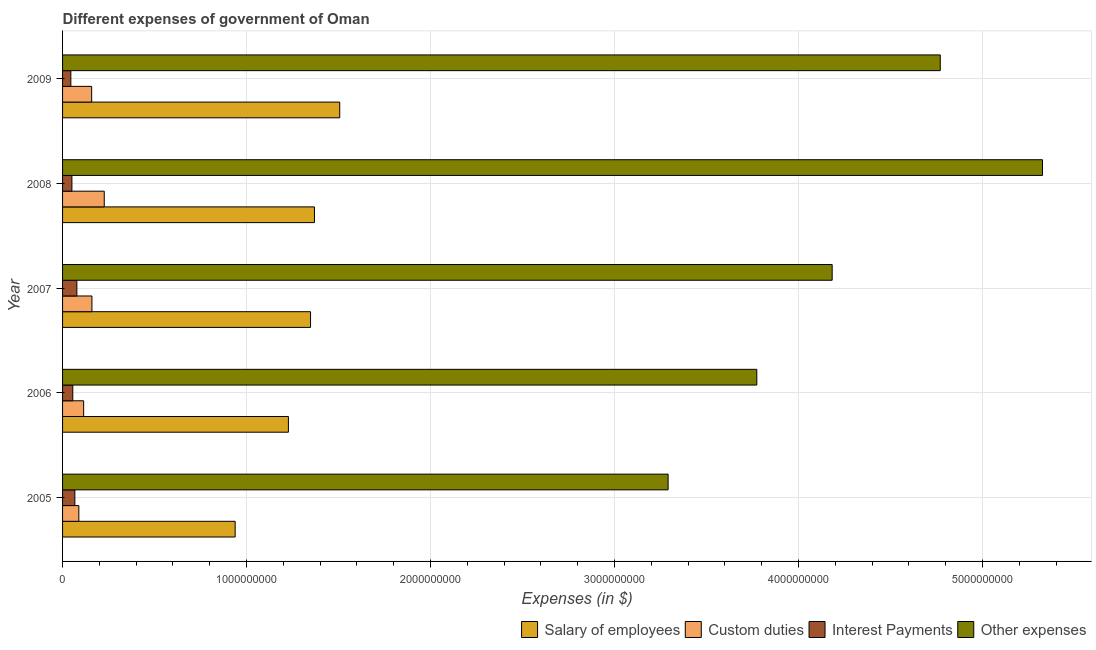Are the number of bars on each tick of the Y-axis equal?
Ensure brevity in your answer.  Yes. How many bars are there on the 1st tick from the bottom?
Keep it short and to the point. 4. What is the label of the 2nd group of bars from the top?
Ensure brevity in your answer.  2008. In how many cases, is the number of bars for a given year not equal to the number of legend labels?
Ensure brevity in your answer.  0. What is the amount spent on interest payments in 2005?
Your answer should be very brief. 6.68e+07. Across all years, what is the maximum amount spent on custom duties?
Make the answer very short. 2.27e+08. Across all years, what is the minimum amount spent on interest payments?
Your response must be concise. 4.50e+07. In which year was the amount spent on interest payments maximum?
Offer a very short reply. 2007. What is the total amount spent on custom duties in the graph?
Ensure brevity in your answer.  7.47e+08. What is the difference between the amount spent on other expenses in 2005 and that in 2007?
Ensure brevity in your answer.  -8.92e+08. What is the difference between the amount spent on salary of employees in 2009 and the amount spent on custom duties in 2005?
Make the answer very short. 1.42e+09. What is the average amount spent on salary of employees per year?
Offer a terse response. 1.28e+09. In the year 2005, what is the difference between the amount spent on interest payments and amount spent on custom duties?
Your response must be concise. -2.17e+07. In how many years, is the amount spent on custom duties greater than 3600000000 $?
Give a very brief answer. 0. What is the ratio of the amount spent on salary of employees in 2006 to that in 2009?
Your answer should be very brief. 0.81. Is the difference between the amount spent on salary of employees in 2005 and 2007 greater than the difference between the amount spent on other expenses in 2005 and 2007?
Make the answer very short. Yes. What is the difference between the highest and the second highest amount spent on salary of employees?
Offer a terse response. 1.37e+08. What is the difference between the highest and the lowest amount spent on custom duties?
Make the answer very short. 1.38e+08. Is it the case that in every year, the sum of the amount spent on interest payments and amount spent on salary of employees is greater than the sum of amount spent on custom duties and amount spent on other expenses?
Provide a succinct answer. No. What does the 4th bar from the top in 2005 represents?
Give a very brief answer. Salary of employees. What does the 1st bar from the bottom in 2007 represents?
Provide a short and direct response. Salary of employees. Is it the case that in every year, the sum of the amount spent on salary of employees and amount spent on custom duties is greater than the amount spent on interest payments?
Keep it short and to the point. Yes. How many bars are there?
Ensure brevity in your answer.  20. Are all the bars in the graph horizontal?
Give a very brief answer. Yes. What is the difference between two consecutive major ticks on the X-axis?
Ensure brevity in your answer.  1.00e+09. Does the graph contain grids?
Your response must be concise. Yes. Where does the legend appear in the graph?
Your answer should be compact. Bottom right. How many legend labels are there?
Keep it short and to the point. 4. How are the legend labels stacked?
Make the answer very short. Horizontal. What is the title of the graph?
Offer a very short reply. Different expenses of government of Oman. Does "First 20% of population" appear as one of the legend labels in the graph?
Your response must be concise. No. What is the label or title of the X-axis?
Your response must be concise. Expenses (in $). What is the label or title of the Y-axis?
Your answer should be compact. Year. What is the Expenses (in $) of Salary of employees in 2005?
Ensure brevity in your answer.  9.38e+08. What is the Expenses (in $) in Custom duties in 2005?
Give a very brief answer. 8.85e+07. What is the Expenses (in $) in Interest Payments in 2005?
Give a very brief answer. 6.68e+07. What is the Expenses (in $) in Other expenses in 2005?
Your response must be concise. 3.29e+09. What is the Expenses (in $) in Salary of employees in 2006?
Provide a succinct answer. 1.23e+09. What is the Expenses (in $) of Custom duties in 2006?
Keep it short and to the point. 1.15e+08. What is the Expenses (in $) in Interest Payments in 2006?
Your answer should be very brief. 5.56e+07. What is the Expenses (in $) in Other expenses in 2006?
Offer a terse response. 3.77e+09. What is the Expenses (in $) of Salary of employees in 2007?
Make the answer very short. 1.35e+09. What is the Expenses (in $) of Custom duties in 2007?
Give a very brief answer. 1.60e+08. What is the Expenses (in $) in Interest Payments in 2007?
Provide a short and direct response. 7.77e+07. What is the Expenses (in $) of Other expenses in 2007?
Provide a succinct answer. 4.18e+09. What is the Expenses (in $) in Salary of employees in 2008?
Make the answer very short. 1.37e+09. What is the Expenses (in $) in Custom duties in 2008?
Your answer should be compact. 2.27e+08. What is the Expenses (in $) of Interest Payments in 2008?
Provide a short and direct response. 5.08e+07. What is the Expenses (in $) of Other expenses in 2008?
Keep it short and to the point. 5.33e+09. What is the Expenses (in $) of Salary of employees in 2009?
Provide a short and direct response. 1.51e+09. What is the Expenses (in $) in Custom duties in 2009?
Offer a very short reply. 1.58e+08. What is the Expenses (in $) in Interest Payments in 2009?
Your answer should be very brief. 4.50e+07. What is the Expenses (in $) of Other expenses in 2009?
Give a very brief answer. 4.77e+09. Across all years, what is the maximum Expenses (in $) of Salary of employees?
Provide a succinct answer. 1.51e+09. Across all years, what is the maximum Expenses (in $) in Custom duties?
Your answer should be compact. 2.27e+08. Across all years, what is the maximum Expenses (in $) in Interest Payments?
Your response must be concise. 7.77e+07. Across all years, what is the maximum Expenses (in $) in Other expenses?
Provide a short and direct response. 5.33e+09. Across all years, what is the minimum Expenses (in $) in Salary of employees?
Make the answer very short. 9.38e+08. Across all years, what is the minimum Expenses (in $) of Custom duties?
Make the answer very short. 8.85e+07. Across all years, what is the minimum Expenses (in $) of Interest Payments?
Your answer should be very brief. 4.50e+07. Across all years, what is the minimum Expenses (in $) of Other expenses?
Provide a short and direct response. 3.29e+09. What is the total Expenses (in $) of Salary of employees in the graph?
Your answer should be compact. 6.39e+09. What is the total Expenses (in $) in Custom duties in the graph?
Your response must be concise. 7.47e+08. What is the total Expenses (in $) in Interest Payments in the graph?
Offer a terse response. 2.96e+08. What is the total Expenses (in $) in Other expenses in the graph?
Provide a short and direct response. 2.13e+1. What is the difference between the Expenses (in $) in Salary of employees in 2005 and that in 2006?
Give a very brief answer. -2.89e+08. What is the difference between the Expenses (in $) in Custom duties in 2005 and that in 2006?
Offer a very short reply. -2.61e+07. What is the difference between the Expenses (in $) in Interest Payments in 2005 and that in 2006?
Provide a succinct answer. 1.12e+07. What is the difference between the Expenses (in $) of Other expenses in 2005 and that in 2006?
Provide a succinct answer. -4.82e+08. What is the difference between the Expenses (in $) of Salary of employees in 2005 and that in 2007?
Keep it short and to the point. -4.10e+08. What is the difference between the Expenses (in $) of Custom duties in 2005 and that in 2007?
Your response must be concise. -7.11e+07. What is the difference between the Expenses (in $) in Interest Payments in 2005 and that in 2007?
Your answer should be compact. -1.09e+07. What is the difference between the Expenses (in $) of Other expenses in 2005 and that in 2007?
Ensure brevity in your answer.  -8.92e+08. What is the difference between the Expenses (in $) in Salary of employees in 2005 and that in 2008?
Offer a terse response. -4.31e+08. What is the difference between the Expenses (in $) in Custom duties in 2005 and that in 2008?
Provide a succinct answer. -1.38e+08. What is the difference between the Expenses (in $) of Interest Payments in 2005 and that in 2008?
Give a very brief answer. 1.60e+07. What is the difference between the Expenses (in $) of Other expenses in 2005 and that in 2008?
Make the answer very short. -2.03e+09. What is the difference between the Expenses (in $) in Salary of employees in 2005 and that in 2009?
Make the answer very short. -5.68e+08. What is the difference between the Expenses (in $) of Custom duties in 2005 and that in 2009?
Keep it short and to the point. -6.96e+07. What is the difference between the Expenses (in $) in Interest Payments in 2005 and that in 2009?
Your answer should be compact. 2.18e+07. What is the difference between the Expenses (in $) in Other expenses in 2005 and that in 2009?
Offer a terse response. -1.48e+09. What is the difference between the Expenses (in $) of Salary of employees in 2006 and that in 2007?
Ensure brevity in your answer.  -1.20e+08. What is the difference between the Expenses (in $) of Custom duties in 2006 and that in 2007?
Provide a succinct answer. -4.50e+07. What is the difference between the Expenses (in $) in Interest Payments in 2006 and that in 2007?
Offer a very short reply. -2.21e+07. What is the difference between the Expenses (in $) in Other expenses in 2006 and that in 2007?
Provide a short and direct response. -4.10e+08. What is the difference between the Expenses (in $) in Salary of employees in 2006 and that in 2008?
Keep it short and to the point. -1.42e+08. What is the difference between the Expenses (in $) in Custom duties in 2006 and that in 2008?
Ensure brevity in your answer.  -1.12e+08. What is the difference between the Expenses (in $) in Interest Payments in 2006 and that in 2008?
Offer a very short reply. 4.80e+06. What is the difference between the Expenses (in $) in Other expenses in 2006 and that in 2008?
Keep it short and to the point. -1.55e+09. What is the difference between the Expenses (in $) of Salary of employees in 2006 and that in 2009?
Offer a very short reply. -2.79e+08. What is the difference between the Expenses (in $) of Custom duties in 2006 and that in 2009?
Provide a succinct answer. -4.35e+07. What is the difference between the Expenses (in $) of Interest Payments in 2006 and that in 2009?
Ensure brevity in your answer.  1.06e+07. What is the difference between the Expenses (in $) in Other expenses in 2006 and that in 2009?
Ensure brevity in your answer.  -9.97e+08. What is the difference between the Expenses (in $) in Salary of employees in 2007 and that in 2008?
Your answer should be compact. -2.13e+07. What is the difference between the Expenses (in $) of Custom duties in 2007 and that in 2008?
Offer a very short reply. -6.70e+07. What is the difference between the Expenses (in $) in Interest Payments in 2007 and that in 2008?
Your response must be concise. 2.69e+07. What is the difference between the Expenses (in $) of Other expenses in 2007 and that in 2008?
Keep it short and to the point. -1.14e+09. What is the difference between the Expenses (in $) in Salary of employees in 2007 and that in 2009?
Offer a very short reply. -1.59e+08. What is the difference between the Expenses (in $) in Custom duties in 2007 and that in 2009?
Your answer should be compact. 1.50e+06. What is the difference between the Expenses (in $) of Interest Payments in 2007 and that in 2009?
Give a very brief answer. 3.27e+07. What is the difference between the Expenses (in $) in Other expenses in 2007 and that in 2009?
Your answer should be compact. -5.88e+08. What is the difference between the Expenses (in $) in Salary of employees in 2008 and that in 2009?
Your response must be concise. -1.37e+08. What is the difference between the Expenses (in $) in Custom duties in 2008 and that in 2009?
Your answer should be very brief. 6.85e+07. What is the difference between the Expenses (in $) of Interest Payments in 2008 and that in 2009?
Offer a very short reply. 5.80e+06. What is the difference between the Expenses (in $) in Other expenses in 2008 and that in 2009?
Offer a terse response. 5.56e+08. What is the difference between the Expenses (in $) in Salary of employees in 2005 and the Expenses (in $) in Custom duties in 2006?
Offer a terse response. 8.24e+08. What is the difference between the Expenses (in $) of Salary of employees in 2005 and the Expenses (in $) of Interest Payments in 2006?
Give a very brief answer. 8.82e+08. What is the difference between the Expenses (in $) in Salary of employees in 2005 and the Expenses (in $) in Other expenses in 2006?
Give a very brief answer. -2.84e+09. What is the difference between the Expenses (in $) in Custom duties in 2005 and the Expenses (in $) in Interest Payments in 2006?
Your response must be concise. 3.29e+07. What is the difference between the Expenses (in $) in Custom duties in 2005 and the Expenses (in $) in Other expenses in 2006?
Make the answer very short. -3.68e+09. What is the difference between the Expenses (in $) in Interest Payments in 2005 and the Expenses (in $) in Other expenses in 2006?
Give a very brief answer. -3.71e+09. What is the difference between the Expenses (in $) in Salary of employees in 2005 and the Expenses (in $) in Custom duties in 2007?
Keep it short and to the point. 7.78e+08. What is the difference between the Expenses (in $) in Salary of employees in 2005 and the Expenses (in $) in Interest Payments in 2007?
Offer a very short reply. 8.60e+08. What is the difference between the Expenses (in $) in Salary of employees in 2005 and the Expenses (in $) in Other expenses in 2007?
Provide a succinct answer. -3.24e+09. What is the difference between the Expenses (in $) of Custom duties in 2005 and the Expenses (in $) of Interest Payments in 2007?
Keep it short and to the point. 1.08e+07. What is the difference between the Expenses (in $) in Custom duties in 2005 and the Expenses (in $) in Other expenses in 2007?
Provide a succinct answer. -4.09e+09. What is the difference between the Expenses (in $) in Interest Payments in 2005 and the Expenses (in $) in Other expenses in 2007?
Make the answer very short. -4.12e+09. What is the difference between the Expenses (in $) in Salary of employees in 2005 and the Expenses (in $) in Custom duties in 2008?
Make the answer very short. 7.12e+08. What is the difference between the Expenses (in $) of Salary of employees in 2005 and the Expenses (in $) of Interest Payments in 2008?
Provide a short and direct response. 8.87e+08. What is the difference between the Expenses (in $) in Salary of employees in 2005 and the Expenses (in $) in Other expenses in 2008?
Give a very brief answer. -4.39e+09. What is the difference between the Expenses (in $) of Custom duties in 2005 and the Expenses (in $) of Interest Payments in 2008?
Give a very brief answer. 3.77e+07. What is the difference between the Expenses (in $) of Custom duties in 2005 and the Expenses (in $) of Other expenses in 2008?
Offer a very short reply. -5.24e+09. What is the difference between the Expenses (in $) in Interest Payments in 2005 and the Expenses (in $) in Other expenses in 2008?
Offer a terse response. -5.26e+09. What is the difference between the Expenses (in $) in Salary of employees in 2005 and the Expenses (in $) in Custom duties in 2009?
Offer a very short reply. 7.80e+08. What is the difference between the Expenses (in $) in Salary of employees in 2005 and the Expenses (in $) in Interest Payments in 2009?
Your response must be concise. 8.93e+08. What is the difference between the Expenses (in $) of Salary of employees in 2005 and the Expenses (in $) of Other expenses in 2009?
Offer a very short reply. -3.83e+09. What is the difference between the Expenses (in $) in Custom duties in 2005 and the Expenses (in $) in Interest Payments in 2009?
Make the answer very short. 4.35e+07. What is the difference between the Expenses (in $) in Custom duties in 2005 and the Expenses (in $) in Other expenses in 2009?
Keep it short and to the point. -4.68e+09. What is the difference between the Expenses (in $) in Interest Payments in 2005 and the Expenses (in $) in Other expenses in 2009?
Offer a very short reply. -4.70e+09. What is the difference between the Expenses (in $) of Salary of employees in 2006 and the Expenses (in $) of Custom duties in 2007?
Ensure brevity in your answer.  1.07e+09. What is the difference between the Expenses (in $) in Salary of employees in 2006 and the Expenses (in $) in Interest Payments in 2007?
Provide a succinct answer. 1.15e+09. What is the difference between the Expenses (in $) of Salary of employees in 2006 and the Expenses (in $) of Other expenses in 2007?
Your answer should be compact. -2.96e+09. What is the difference between the Expenses (in $) in Custom duties in 2006 and the Expenses (in $) in Interest Payments in 2007?
Your response must be concise. 3.69e+07. What is the difference between the Expenses (in $) in Custom duties in 2006 and the Expenses (in $) in Other expenses in 2007?
Provide a short and direct response. -4.07e+09. What is the difference between the Expenses (in $) in Interest Payments in 2006 and the Expenses (in $) in Other expenses in 2007?
Provide a succinct answer. -4.13e+09. What is the difference between the Expenses (in $) in Salary of employees in 2006 and the Expenses (in $) in Custom duties in 2008?
Make the answer very short. 1.00e+09. What is the difference between the Expenses (in $) in Salary of employees in 2006 and the Expenses (in $) in Interest Payments in 2008?
Offer a terse response. 1.18e+09. What is the difference between the Expenses (in $) in Salary of employees in 2006 and the Expenses (in $) in Other expenses in 2008?
Offer a very short reply. -4.10e+09. What is the difference between the Expenses (in $) in Custom duties in 2006 and the Expenses (in $) in Interest Payments in 2008?
Your answer should be compact. 6.38e+07. What is the difference between the Expenses (in $) in Custom duties in 2006 and the Expenses (in $) in Other expenses in 2008?
Give a very brief answer. -5.21e+09. What is the difference between the Expenses (in $) of Interest Payments in 2006 and the Expenses (in $) of Other expenses in 2008?
Your answer should be very brief. -5.27e+09. What is the difference between the Expenses (in $) of Salary of employees in 2006 and the Expenses (in $) of Custom duties in 2009?
Offer a very short reply. 1.07e+09. What is the difference between the Expenses (in $) of Salary of employees in 2006 and the Expenses (in $) of Interest Payments in 2009?
Offer a very short reply. 1.18e+09. What is the difference between the Expenses (in $) of Salary of employees in 2006 and the Expenses (in $) of Other expenses in 2009?
Give a very brief answer. -3.54e+09. What is the difference between the Expenses (in $) of Custom duties in 2006 and the Expenses (in $) of Interest Payments in 2009?
Your answer should be compact. 6.96e+07. What is the difference between the Expenses (in $) in Custom duties in 2006 and the Expenses (in $) in Other expenses in 2009?
Ensure brevity in your answer.  -4.66e+09. What is the difference between the Expenses (in $) in Interest Payments in 2006 and the Expenses (in $) in Other expenses in 2009?
Offer a very short reply. -4.72e+09. What is the difference between the Expenses (in $) of Salary of employees in 2007 and the Expenses (in $) of Custom duties in 2008?
Your answer should be compact. 1.12e+09. What is the difference between the Expenses (in $) of Salary of employees in 2007 and the Expenses (in $) of Interest Payments in 2008?
Offer a very short reply. 1.30e+09. What is the difference between the Expenses (in $) in Salary of employees in 2007 and the Expenses (in $) in Other expenses in 2008?
Ensure brevity in your answer.  -3.98e+09. What is the difference between the Expenses (in $) of Custom duties in 2007 and the Expenses (in $) of Interest Payments in 2008?
Your answer should be compact. 1.09e+08. What is the difference between the Expenses (in $) in Custom duties in 2007 and the Expenses (in $) in Other expenses in 2008?
Your answer should be very brief. -5.17e+09. What is the difference between the Expenses (in $) in Interest Payments in 2007 and the Expenses (in $) in Other expenses in 2008?
Your answer should be very brief. -5.25e+09. What is the difference between the Expenses (in $) of Salary of employees in 2007 and the Expenses (in $) of Custom duties in 2009?
Your answer should be compact. 1.19e+09. What is the difference between the Expenses (in $) in Salary of employees in 2007 and the Expenses (in $) in Interest Payments in 2009?
Provide a short and direct response. 1.30e+09. What is the difference between the Expenses (in $) in Salary of employees in 2007 and the Expenses (in $) in Other expenses in 2009?
Your answer should be very brief. -3.42e+09. What is the difference between the Expenses (in $) of Custom duties in 2007 and the Expenses (in $) of Interest Payments in 2009?
Your response must be concise. 1.15e+08. What is the difference between the Expenses (in $) of Custom duties in 2007 and the Expenses (in $) of Other expenses in 2009?
Keep it short and to the point. -4.61e+09. What is the difference between the Expenses (in $) in Interest Payments in 2007 and the Expenses (in $) in Other expenses in 2009?
Your answer should be compact. -4.69e+09. What is the difference between the Expenses (in $) in Salary of employees in 2008 and the Expenses (in $) in Custom duties in 2009?
Your response must be concise. 1.21e+09. What is the difference between the Expenses (in $) of Salary of employees in 2008 and the Expenses (in $) of Interest Payments in 2009?
Ensure brevity in your answer.  1.32e+09. What is the difference between the Expenses (in $) of Salary of employees in 2008 and the Expenses (in $) of Other expenses in 2009?
Offer a very short reply. -3.40e+09. What is the difference between the Expenses (in $) of Custom duties in 2008 and the Expenses (in $) of Interest Payments in 2009?
Provide a short and direct response. 1.82e+08. What is the difference between the Expenses (in $) in Custom duties in 2008 and the Expenses (in $) in Other expenses in 2009?
Your response must be concise. -4.54e+09. What is the difference between the Expenses (in $) in Interest Payments in 2008 and the Expenses (in $) in Other expenses in 2009?
Your answer should be very brief. -4.72e+09. What is the average Expenses (in $) in Salary of employees per year?
Provide a succinct answer. 1.28e+09. What is the average Expenses (in $) of Custom duties per year?
Give a very brief answer. 1.49e+08. What is the average Expenses (in $) of Interest Payments per year?
Offer a terse response. 5.92e+07. What is the average Expenses (in $) in Other expenses per year?
Keep it short and to the point. 4.27e+09. In the year 2005, what is the difference between the Expenses (in $) in Salary of employees and Expenses (in $) in Custom duties?
Make the answer very short. 8.50e+08. In the year 2005, what is the difference between the Expenses (in $) of Salary of employees and Expenses (in $) of Interest Payments?
Make the answer very short. 8.71e+08. In the year 2005, what is the difference between the Expenses (in $) of Salary of employees and Expenses (in $) of Other expenses?
Provide a short and direct response. -2.35e+09. In the year 2005, what is the difference between the Expenses (in $) in Custom duties and Expenses (in $) in Interest Payments?
Your answer should be compact. 2.17e+07. In the year 2005, what is the difference between the Expenses (in $) of Custom duties and Expenses (in $) of Other expenses?
Give a very brief answer. -3.20e+09. In the year 2005, what is the difference between the Expenses (in $) of Interest Payments and Expenses (in $) of Other expenses?
Offer a terse response. -3.22e+09. In the year 2006, what is the difference between the Expenses (in $) in Salary of employees and Expenses (in $) in Custom duties?
Keep it short and to the point. 1.11e+09. In the year 2006, what is the difference between the Expenses (in $) of Salary of employees and Expenses (in $) of Interest Payments?
Offer a terse response. 1.17e+09. In the year 2006, what is the difference between the Expenses (in $) in Salary of employees and Expenses (in $) in Other expenses?
Your response must be concise. -2.55e+09. In the year 2006, what is the difference between the Expenses (in $) of Custom duties and Expenses (in $) of Interest Payments?
Offer a terse response. 5.90e+07. In the year 2006, what is the difference between the Expenses (in $) of Custom duties and Expenses (in $) of Other expenses?
Offer a very short reply. -3.66e+09. In the year 2006, what is the difference between the Expenses (in $) of Interest Payments and Expenses (in $) of Other expenses?
Your answer should be compact. -3.72e+09. In the year 2007, what is the difference between the Expenses (in $) of Salary of employees and Expenses (in $) of Custom duties?
Your response must be concise. 1.19e+09. In the year 2007, what is the difference between the Expenses (in $) in Salary of employees and Expenses (in $) in Interest Payments?
Offer a very short reply. 1.27e+09. In the year 2007, what is the difference between the Expenses (in $) of Salary of employees and Expenses (in $) of Other expenses?
Offer a terse response. -2.84e+09. In the year 2007, what is the difference between the Expenses (in $) of Custom duties and Expenses (in $) of Interest Payments?
Offer a very short reply. 8.19e+07. In the year 2007, what is the difference between the Expenses (in $) of Custom duties and Expenses (in $) of Other expenses?
Your answer should be very brief. -4.02e+09. In the year 2007, what is the difference between the Expenses (in $) in Interest Payments and Expenses (in $) in Other expenses?
Your response must be concise. -4.11e+09. In the year 2008, what is the difference between the Expenses (in $) in Salary of employees and Expenses (in $) in Custom duties?
Keep it short and to the point. 1.14e+09. In the year 2008, what is the difference between the Expenses (in $) of Salary of employees and Expenses (in $) of Interest Payments?
Your answer should be very brief. 1.32e+09. In the year 2008, what is the difference between the Expenses (in $) of Salary of employees and Expenses (in $) of Other expenses?
Keep it short and to the point. -3.96e+09. In the year 2008, what is the difference between the Expenses (in $) of Custom duties and Expenses (in $) of Interest Payments?
Your answer should be very brief. 1.76e+08. In the year 2008, what is the difference between the Expenses (in $) of Custom duties and Expenses (in $) of Other expenses?
Your answer should be compact. -5.10e+09. In the year 2008, what is the difference between the Expenses (in $) in Interest Payments and Expenses (in $) in Other expenses?
Give a very brief answer. -5.28e+09. In the year 2009, what is the difference between the Expenses (in $) in Salary of employees and Expenses (in $) in Custom duties?
Offer a terse response. 1.35e+09. In the year 2009, what is the difference between the Expenses (in $) in Salary of employees and Expenses (in $) in Interest Payments?
Ensure brevity in your answer.  1.46e+09. In the year 2009, what is the difference between the Expenses (in $) in Salary of employees and Expenses (in $) in Other expenses?
Your response must be concise. -3.26e+09. In the year 2009, what is the difference between the Expenses (in $) of Custom duties and Expenses (in $) of Interest Payments?
Your answer should be compact. 1.13e+08. In the year 2009, what is the difference between the Expenses (in $) in Custom duties and Expenses (in $) in Other expenses?
Keep it short and to the point. -4.61e+09. In the year 2009, what is the difference between the Expenses (in $) in Interest Payments and Expenses (in $) in Other expenses?
Your answer should be compact. -4.73e+09. What is the ratio of the Expenses (in $) in Salary of employees in 2005 to that in 2006?
Your response must be concise. 0.76. What is the ratio of the Expenses (in $) in Custom duties in 2005 to that in 2006?
Provide a succinct answer. 0.77. What is the ratio of the Expenses (in $) in Interest Payments in 2005 to that in 2006?
Your answer should be compact. 1.2. What is the ratio of the Expenses (in $) of Other expenses in 2005 to that in 2006?
Your response must be concise. 0.87. What is the ratio of the Expenses (in $) of Salary of employees in 2005 to that in 2007?
Make the answer very short. 0.7. What is the ratio of the Expenses (in $) in Custom duties in 2005 to that in 2007?
Offer a very short reply. 0.55. What is the ratio of the Expenses (in $) of Interest Payments in 2005 to that in 2007?
Offer a very short reply. 0.86. What is the ratio of the Expenses (in $) in Other expenses in 2005 to that in 2007?
Offer a terse response. 0.79. What is the ratio of the Expenses (in $) in Salary of employees in 2005 to that in 2008?
Offer a terse response. 0.69. What is the ratio of the Expenses (in $) in Custom duties in 2005 to that in 2008?
Your answer should be very brief. 0.39. What is the ratio of the Expenses (in $) in Interest Payments in 2005 to that in 2008?
Make the answer very short. 1.31. What is the ratio of the Expenses (in $) in Other expenses in 2005 to that in 2008?
Make the answer very short. 0.62. What is the ratio of the Expenses (in $) in Salary of employees in 2005 to that in 2009?
Your answer should be compact. 0.62. What is the ratio of the Expenses (in $) of Custom duties in 2005 to that in 2009?
Make the answer very short. 0.56. What is the ratio of the Expenses (in $) in Interest Payments in 2005 to that in 2009?
Your answer should be very brief. 1.48. What is the ratio of the Expenses (in $) in Other expenses in 2005 to that in 2009?
Ensure brevity in your answer.  0.69. What is the ratio of the Expenses (in $) in Salary of employees in 2006 to that in 2007?
Make the answer very short. 0.91. What is the ratio of the Expenses (in $) in Custom duties in 2006 to that in 2007?
Make the answer very short. 0.72. What is the ratio of the Expenses (in $) of Interest Payments in 2006 to that in 2007?
Your response must be concise. 0.72. What is the ratio of the Expenses (in $) in Other expenses in 2006 to that in 2007?
Your answer should be compact. 0.9. What is the ratio of the Expenses (in $) of Salary of employees in 2006 to that in 2008?
Give a very brief answer. 0.9. What is the ratio of the Expenses (in $) of Custom duties in 2006 to that in 2008?
Ensure brevity in your answer.  0.51. What is the ratio of the Expenses (in $) in Interest Payments in 2006 to that in 2008?
Your answer should be compact. 1.09. What is the ratio of the Expenses (in $) of Other expenses in 2006 to that in 2008?
Make the answer very short. 0.71. What is the ratio of the Expenses (in $) in Salary of employees in 2006 to that in 2009?
Make the answer very short. 0.81. What is the ratio of the Expenses (in $) of Custom duties in 2006 to that in 2009?
Offer a terse response. 0.72. What is the ratio of the Expenses (in $) of Interest Payments in 2006 to that in 2009?
Offer a terse response. 1.24. What is the ratio of the Expenses (in $) of Other expenses in 2006 to that in 2009?
Your answer should be compact. 0.79. What is the ratio of the Expenses (in $) of Salary of employees in 2007 to that in 2008?
Offer a terse response. 0.98. What is the ratio of the Expenses (in $) in Custom duties in 2007 to that in 2008?
Your answer should be compact. 0.7. What is the ratio of the Expenses (in $) in Interest Payments in 2007 to that in 2008?
Keep it short and to the point. 1.53. What is the ratio of the Expenses (in $) of Other expenses in 2007 to that in 2008?
Give a very brief answer. 0.79. What is the ratio of the Expenses (in $) in Salary of employees in 2007 to that in 2009?
Make the answer very short. 0.89. What is the ratio of the Expenses (in $) in Custom duties in 2007 to that in 2009?
Your answer should be compact. 1.01. What is the ratio of the Expenses (in $) in Interest Payments in 2007 to that in 2009?
Make the answer very short. 1.73. What is the ratio of the Expenses (in $) in Other expenses in 2007 to that in 2009?
Ensure brevity in your answer.  0.88. What is the ratio of the Expenses (in $) in Salary of employees in 2008 to that in 2009?
Make the answer very short. 0.91. What is the ratio of the Expenses (in $) of Custom duties in 2008 to that in 2009?
Offer a terse response. 1.43. What is the ratio of the Expenses (in $) of Interest Payments in 2008 to that in 2009?
Your response must be concise. 1.13. What is the ratio of the Expenses (in $) of Other expenses in 2008 to that in 2009?
Your answer should be compact. 1.12. What is the difference between the highest and the second highest Expenses (in $) of Salary of employees?
Your answer should be very brief. 1.37e+08. What is the difference between the highest and the second highest Expenses (in $) of Custom duties?
Provide a short and direct response. 6.70e+07. What is the difference between the highest and the second highest Expenses (in $) of Interest Payments?
Ensure brevity in your answer.  1.09e+07. What is the difference between the highest and the second highest Expenses (in $) in Other expenses?
Offer a very short reply. 5.56e+08. What is the difference between the highest and the lowest Expenses (in $) of Salary of employees?
Provide a succinct answer. 5.68e+08. What is the difference between the highest and the lowest Expenses (in $) of Custom duties?
Make the answer very short. 1.38e+08. What is the difference between the highest and the lowest Expenses (in $) in Interest Payments?
Keep it short and to the point. 3.27e+07. What is the difference between the highest and the lowest Expenses (in $) of Other expenses?
Ensure brevity in your answer.  2.03e+09. 